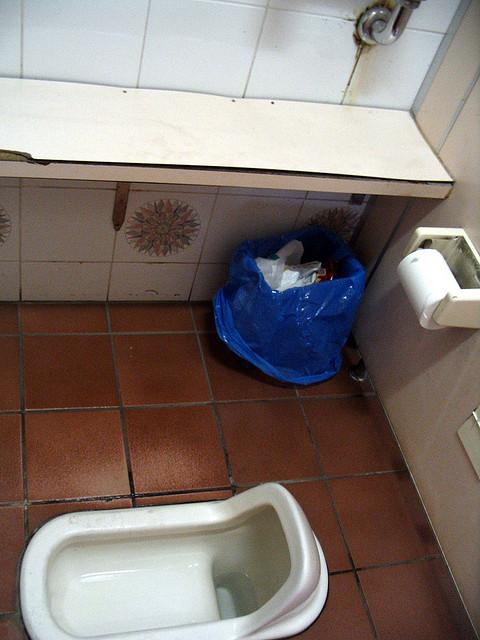Is the trash full?
Concise answer only. Yes. What room is this?
Answer briefly. Bathroom. Can you see the flush for the toilet?
Give a very brief answer. No. 